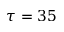<formula> <loc_0><loc_0><loc_500><loc_500>\tau = 3 5</formula> 